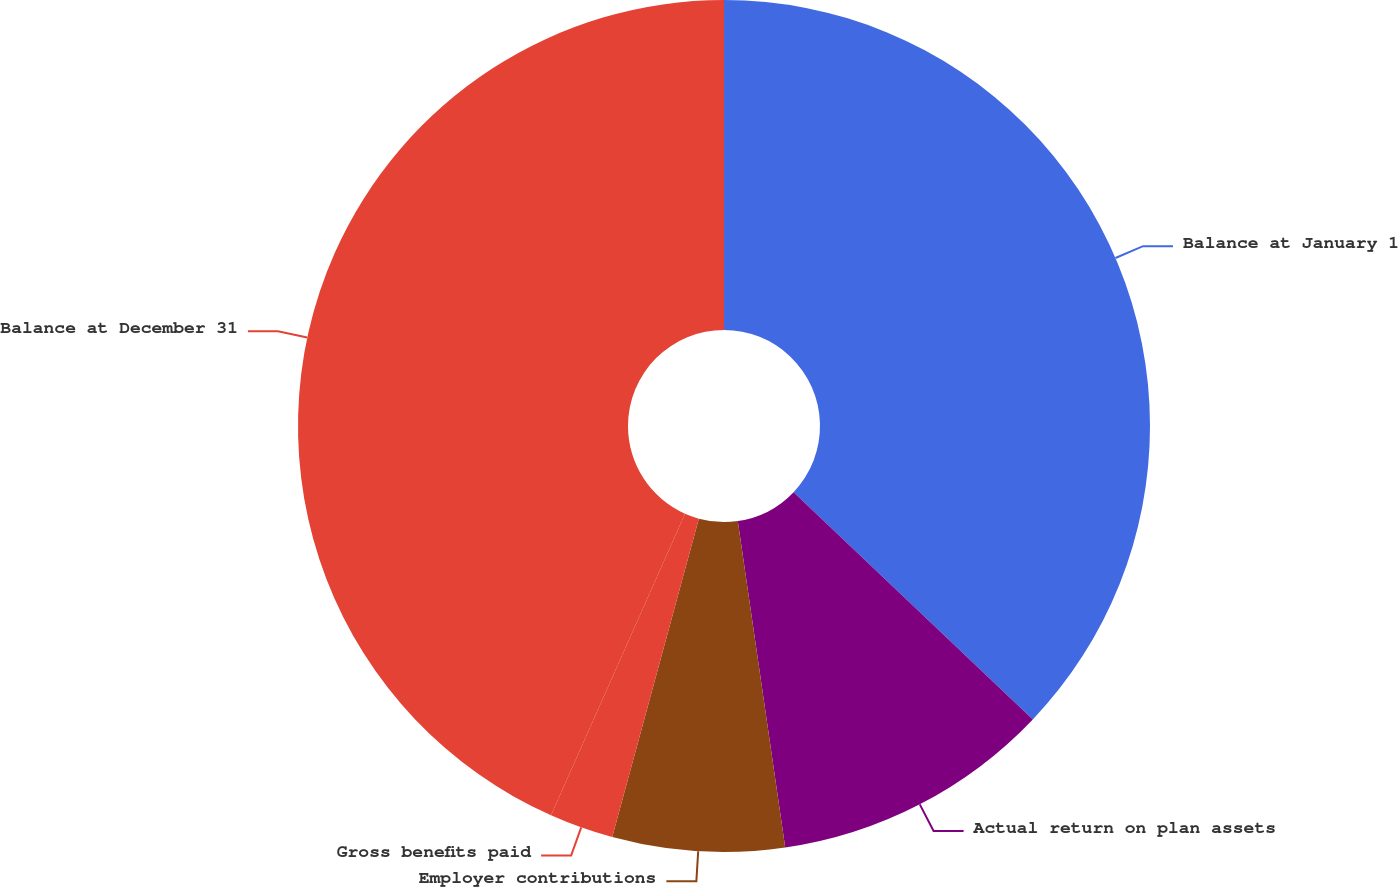Convert chart to OTSL. <chart><loc_0><loc_0><loc_500><loc_500><pie_chart><fcel>Balance at January 1<fcel>Actual return on plan assets<fcel>Employer contributions<fcel>Gross benefits paid<fcel>Balance at December 31<nl><fcel>37.09%<fcel>10.61%<fcel>6.52%<fcel>2.43%<fcel>43.34%<nl></chart> 